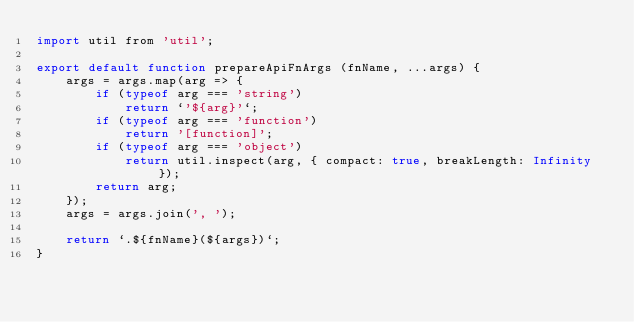Convert code to text. <code><loc_0><loc_0><loc_500><loc_500><_JavaScript_>import util from 'util';

export default function prepareApiFnArgs (fnName, ...args) {
    args = args.map(arg => {
        if (typeof arg === 'string')
            return `'${arg}'`;
        if (typeof arg === 'function')
            return '[function]';
        if (typeof arg === 'object')
            return util.inspect(arg, { compact: true, breakLength: Infinity });
        return arg;
    });
    args = args.join(', ');

    return `.${fnName}(${args})`;
}
</code> 